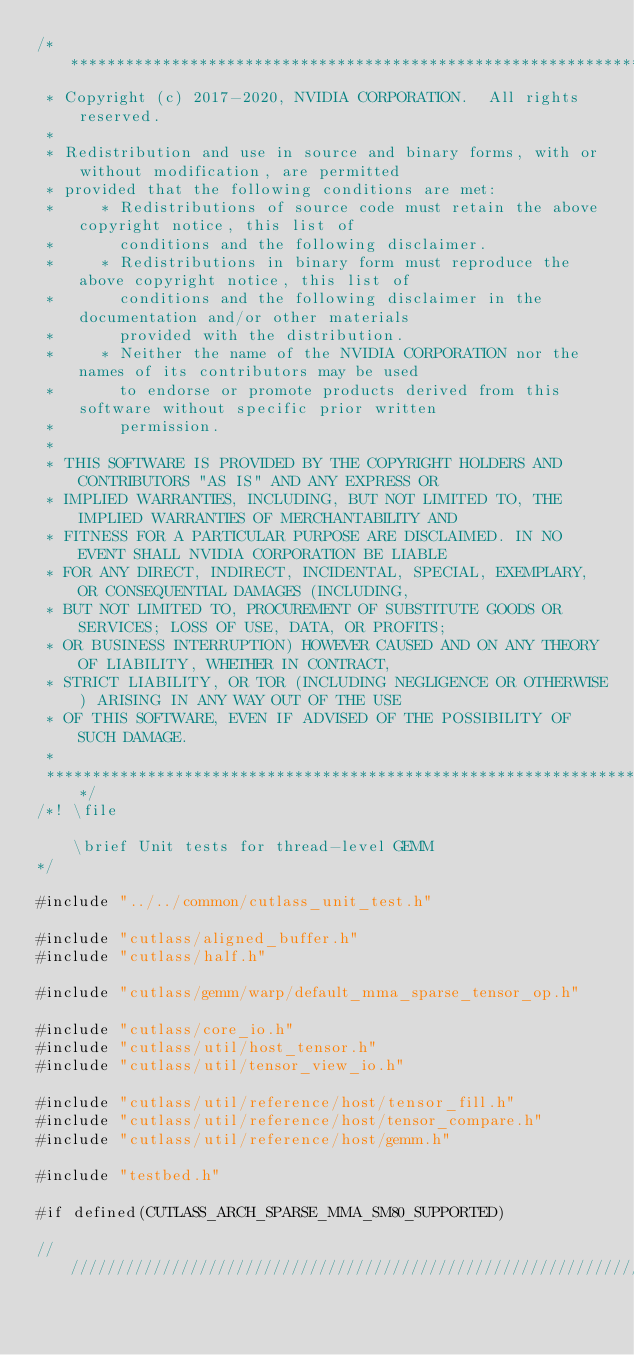Convert code to text. <code><loc_0><loc_0><loc_500><loc_500><_Cuda_>/***************************************************************************************************
 * Copyright (c) 2017-2020, NVIDIA CORPORATION.  All rights reserved.
 *
 * Redistribution and use in source and binary forms, with or without modification, are permitted
 * provided that the following conditions are met:
 *     * Redistributions of source code must retain the above copyright notice, this list of
 *       conditions and the following disclaimer.
 *     * Redistributions in binary form must reproduce the above copyright notice, this list of
 *       conditions and the following disclaimer in the documentation and/or other materials
 *       provided with the distribution.
 *     * Neither the name of the NVIDIA CORPORATION nor the names of its contributors may be used
 *       to endorse or promote products derived from this software without specific prior written
 *       permission.
 *
 * THIS SOFTWARE IS PROVIDED BY THE COPYRIGHT HOLDERS AND CONTRIBUTORS "AS IS" AND ANY EXPRESS OR
 * IMPLIED WARRANTIES, INCLUDING, BUT NOT LIMITED TO, THE IMPLIED WARRANTIES OF MERCHANTABILITY AND
 * FITNESS FOR A PARTICULAR PURPOSE ARE DISCLAIMED. IN NO EVENT SHALL NVIDIA CORPORATION BE LIABLE
 * FOR ANY DIRECT, INDIRECT, INCIDENTAL, SPECIAL, EXEMPLARY, OR CONSEQUENTIAL DAMAGES (INCLUDING,
 * BUT NOT LIMITED TO, PROCUREMENT OF SUBSTITUTE GOODS OR SERVICES; LOSS OF USE, DATA, OR PROFITS;
 * OR BUSINESS INTERRUPTION) HOWEVER CAUSED AND ON ANY THEORY OF LIABILITY, WHETHER IN CONTRACT,
 * STRICT LIABILITY, OR TOR (INCLUDING NEGLIGENCE OR OTHERWISE) ARISING IN ANY WAY OUT OF THE USE
 * OF THIS SOFTWARE, EVEN IF ADVISED OF THE POSSIBILITY OF SUCH DAMAGE.
 *
 **************************************************************************************************/
/*! \file 

    \brief Unit tests for thread-level GEMM
*/

#include "../../common/cutlass_unit_test.h"

#include "cutlass/aligned_buffer.h"
#include "cutlass/half.h"

#include "cutlass/gemm/warp/default_mma_sparse_tensor_op.h"

#include "cutlass/core_io.h"
#include "cutlass/util/host_tensor.h"
#include "cutlass/util/tensor_view_io.h"

#include "cutlass/util/reference/host/tensor_fill.h"
#include "cutlass/util/reference/host/tensor_compare.h"
#include "cutlass/util/reference/host/gemm.h"

#include "testbed.h"

#if defined(CUTLASS_ARCH_SPARSE_MMA_SM80_SUPPORTED)

////////////////////////////////////////////////////////////////////////////////
</code> 